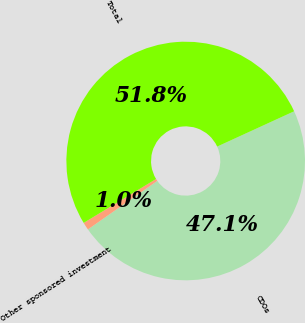Convert chart. <chart><loc_0><loc_0><loc_500><loc_500><pie_chart><fcel>CDOs<fcel>Other sponsored investment<fcel>Total<nl><fcel>47.13%<fcel>1.04%<fcel>51.84%<nl></chart> 